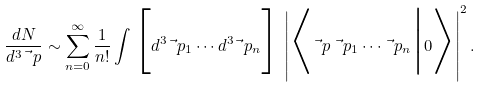<formula> <loc_0><loc_0><loc_500><loc_500>\frac { d N } { d ^ { 3 } \vec { \ } p } \sim \sum _ { n = 0 } ^ { \infty } \frac { 1 } { n ! } \int \Big [ d ^ { 3 } \vec { \ } p _ { 1 } \cdots d ^ { 3 } \vec { \ } p _ { n } \Big ] \, \left | \Big < { \vec { \ } p } \, \vec { \ } p _ { 1 } \cdots \vec { \ } p _ { n } \Big | 0 \Big > \right | ^ { 2 } .</formula> 